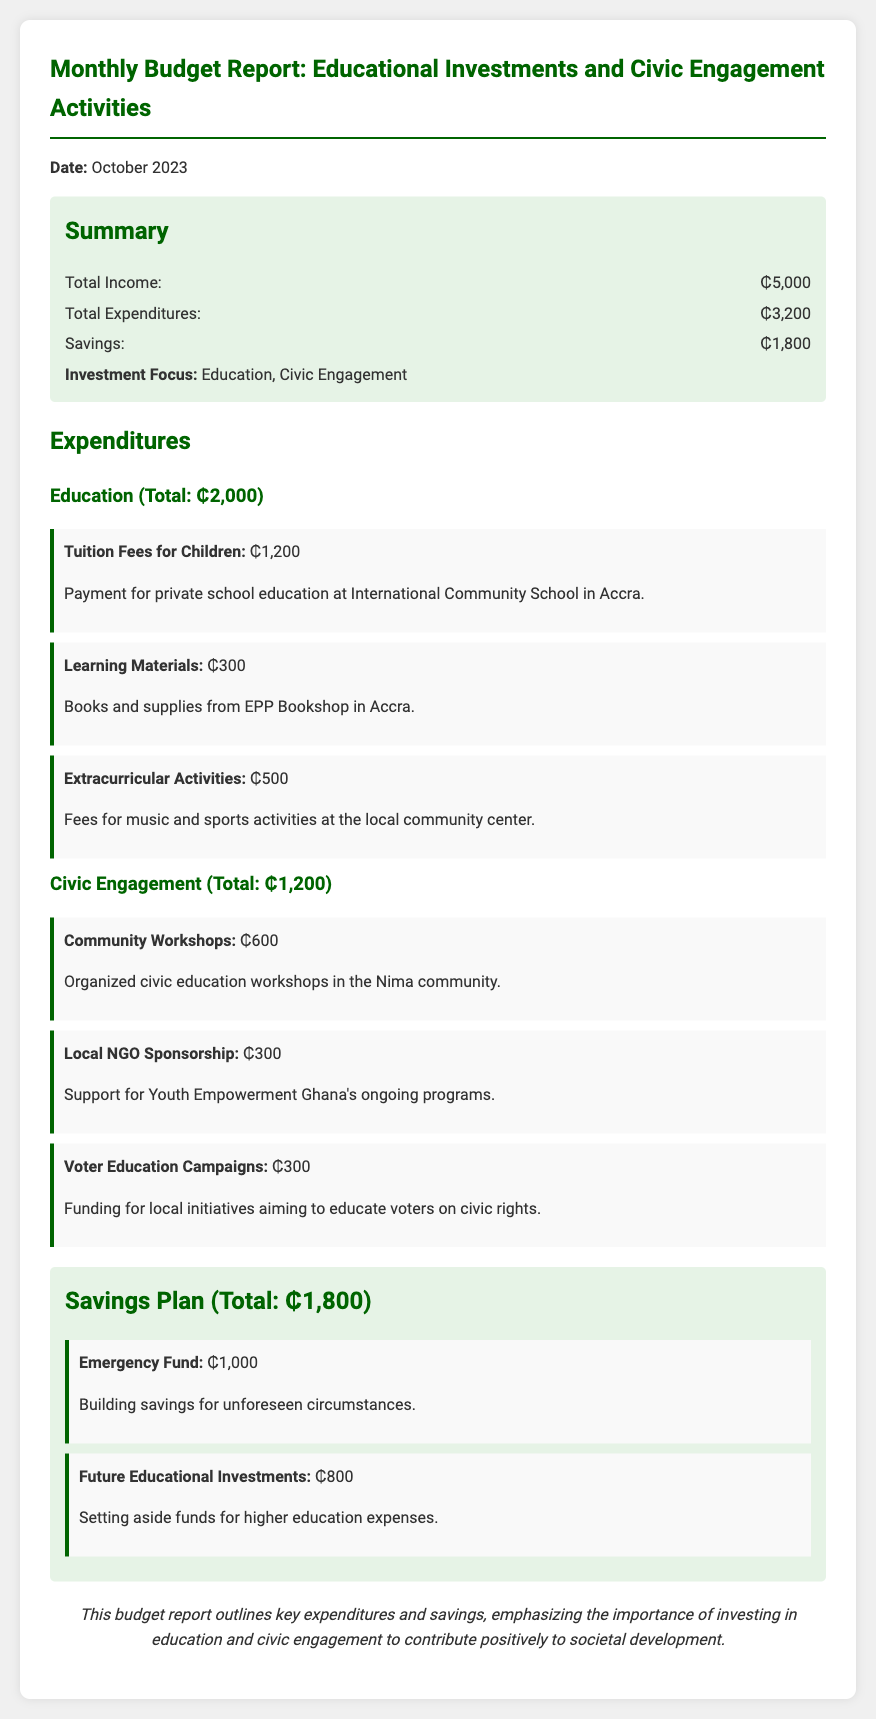What is the total income? The total income is listed in the summary section of the document.
Answer: ₵5,000 What is the total expenditure on education? The total expenditure on education is provided under the expenditures section specifically for education.
Answer: ₵2,000 How much is allocated for community workshops? The amount allocated for community workshops is specified in the civic engagement section of expenditures.
Answer: ₵600 What is the total savings amount? The total savings is detailed in the savings plan section of the document.
Answer: ₵1,800 How much is spent on tuition fees for children? The amount spent on tuition fees for children is provided in the educational expenditures section.
Answer: ₵1,200 What is the focus of the investment mentioned in the summary? The investment focus is stated directly under the summary section of the document.
Answer: Education, Civic Engagement What amount is set aside for the emergency fund? The amount set aside for the emergency fund is listed in the savings plan section.
Answer: ₵1,000 What is the purpose of the voter education campaigns? The purpose of the voter education campaigns is explained in the civic engagement expenditures, providing details about funding for education on civic rights.
Answer: Educate voters on civic rights How much is allocated for future educational investments? The allocation for future educational investments is given in the savings plan section.
Answer: ₵800 